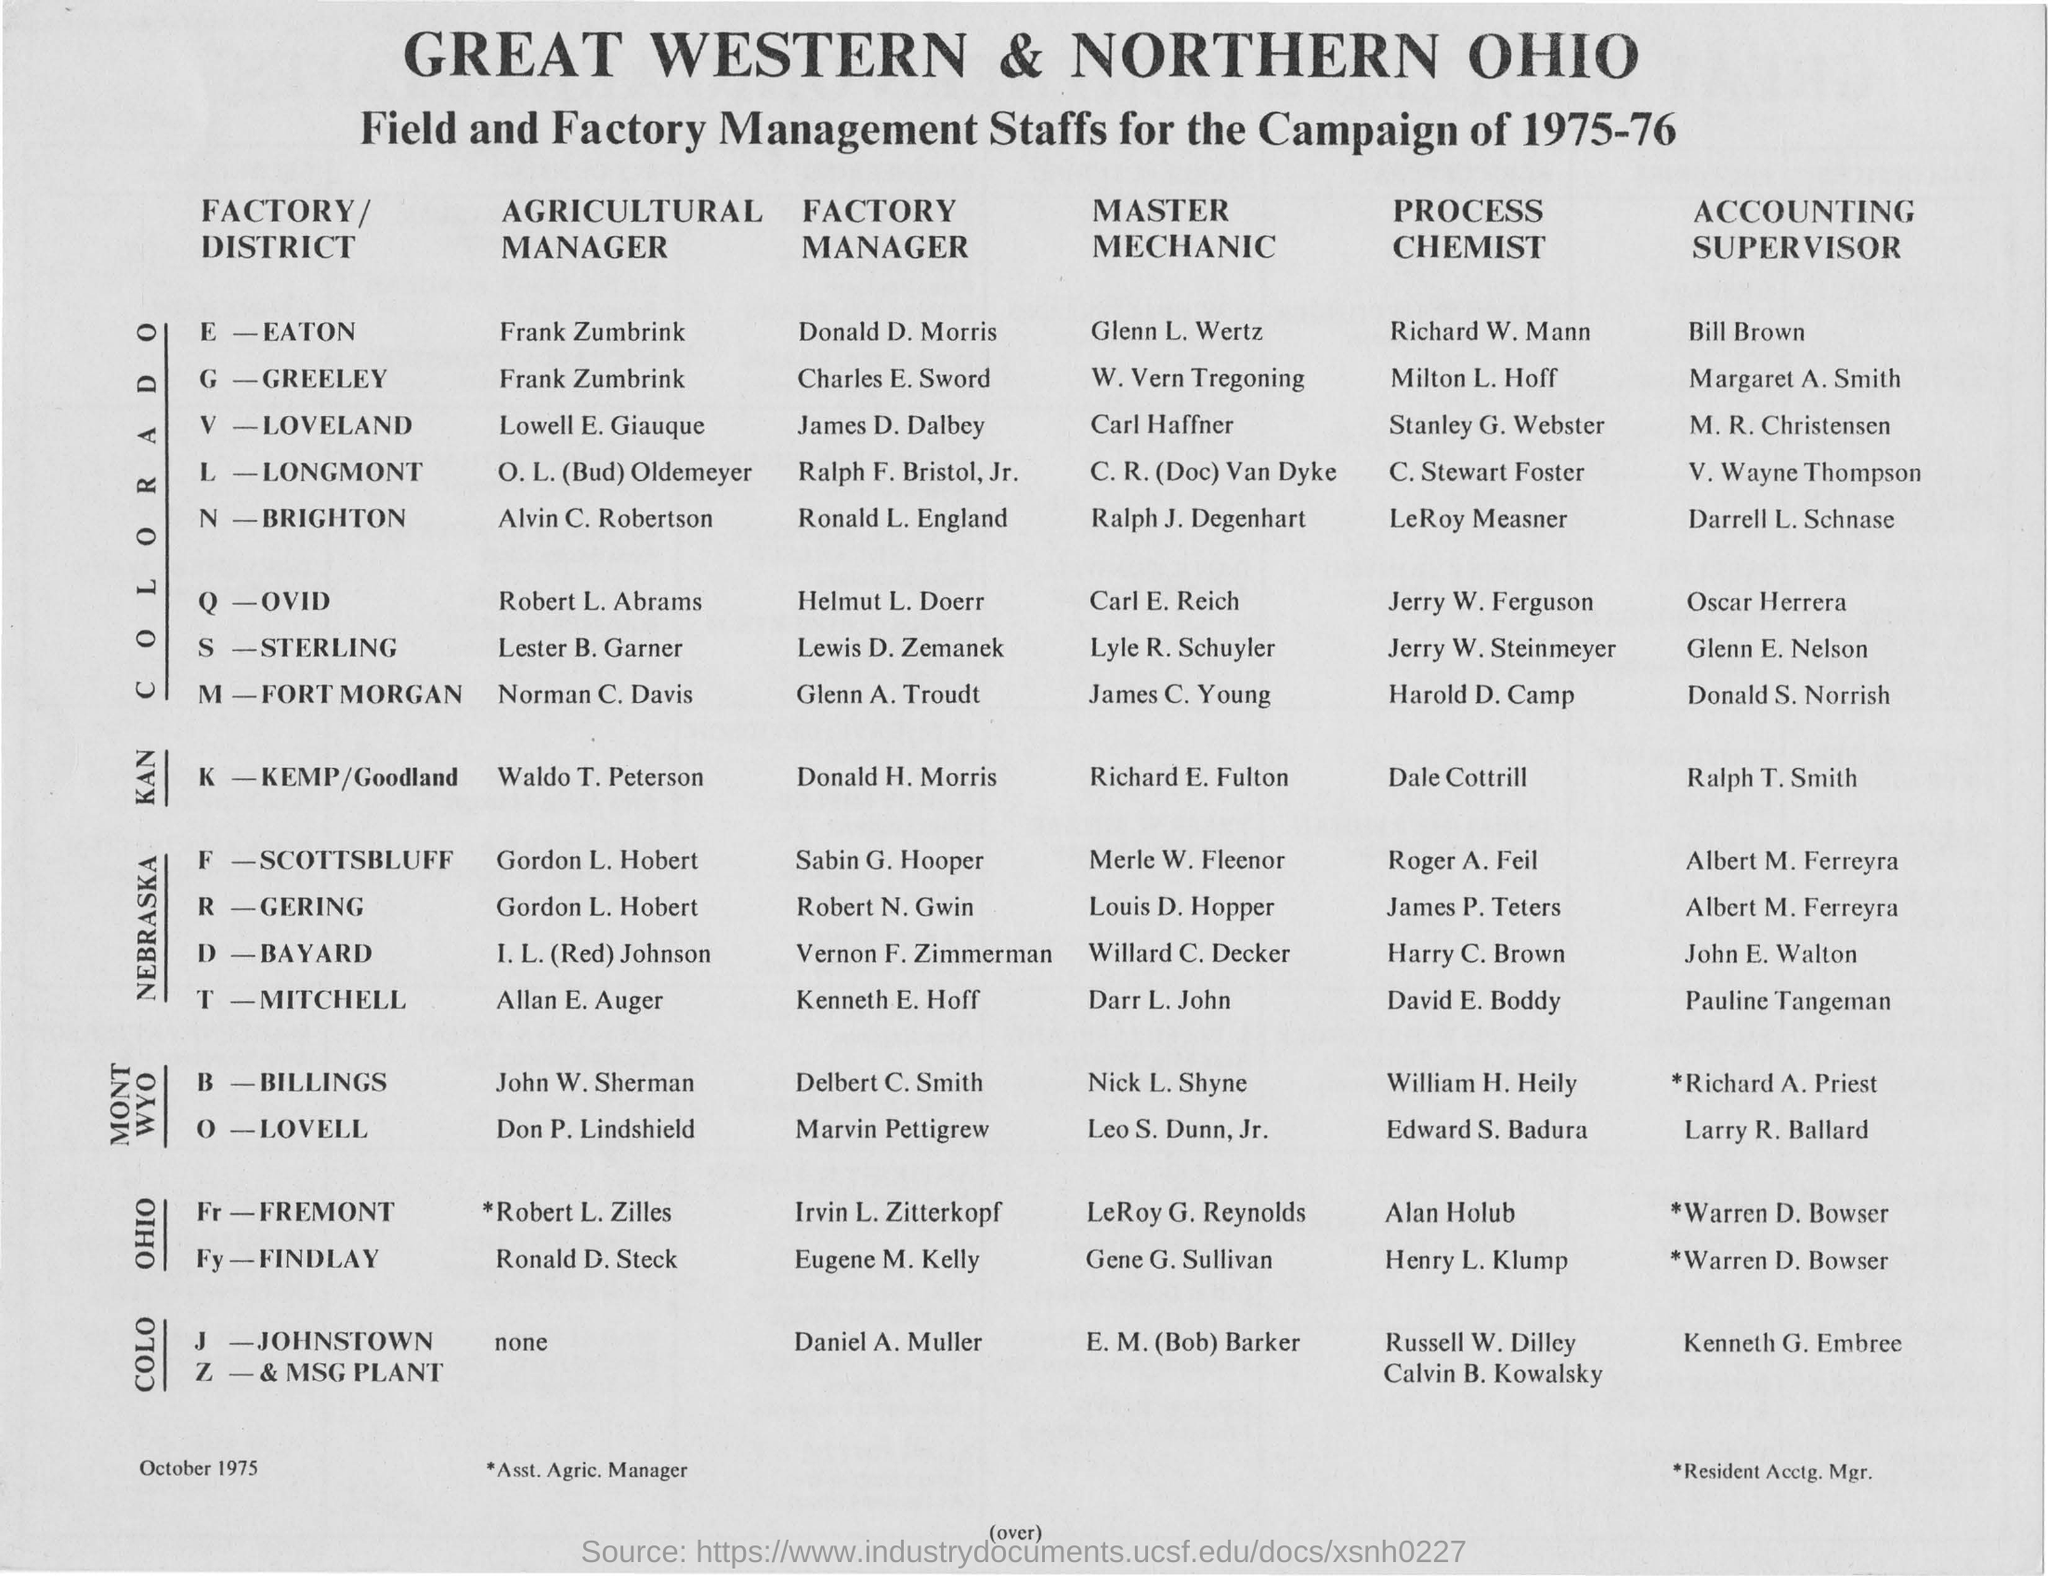Point out several critical features in this image. The year mentioned at the top of the document is 1975-76. The individual named Glenn E. Nelson is the Accounting Supervisor of the S-STERLING. The Agricultural Manager of the N-BRIGHTON is Alvin C. Robertson. The Master of Mechanics at Q-OVID is Carl E. Reich. The person who is the Factory Manager of E-EATON is named Donald D. Morris. 